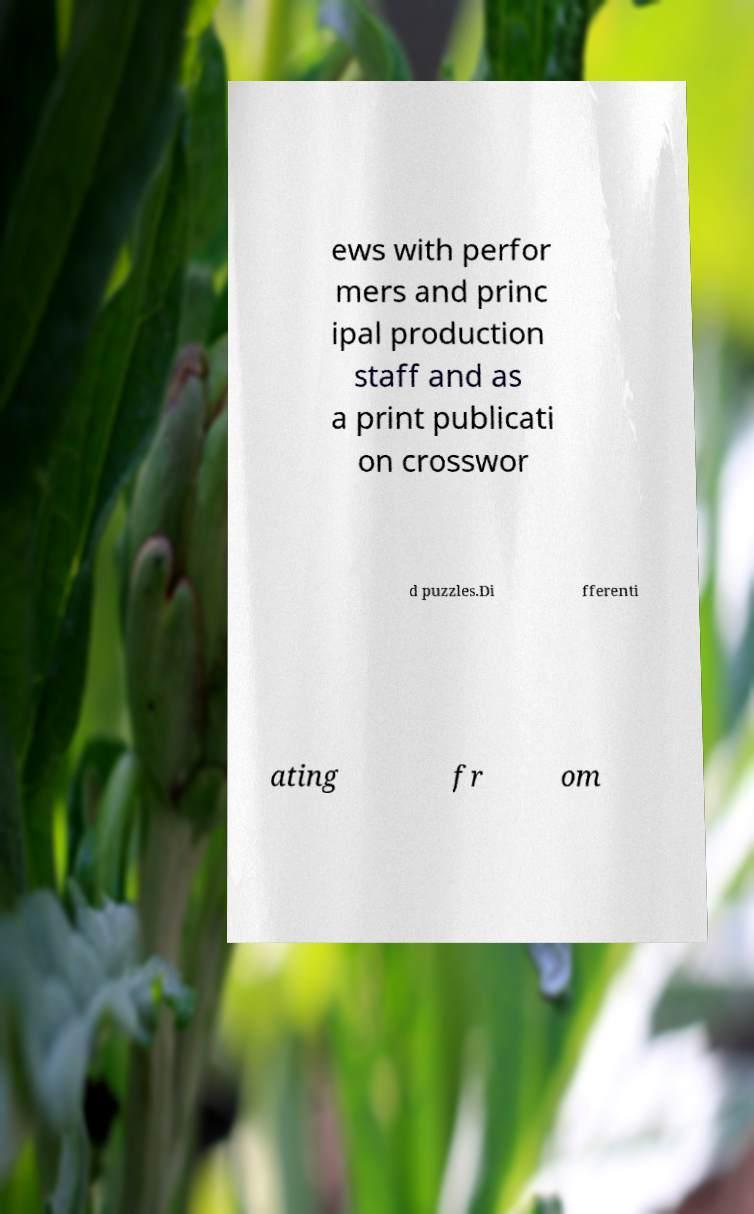For documentation purposes, I need the text within this image transcribed. Could you provide that? ews with perfor mers and princ ipal production staff and as a print publicati on crosswor d puzzles.Di fferenti ating fr om 